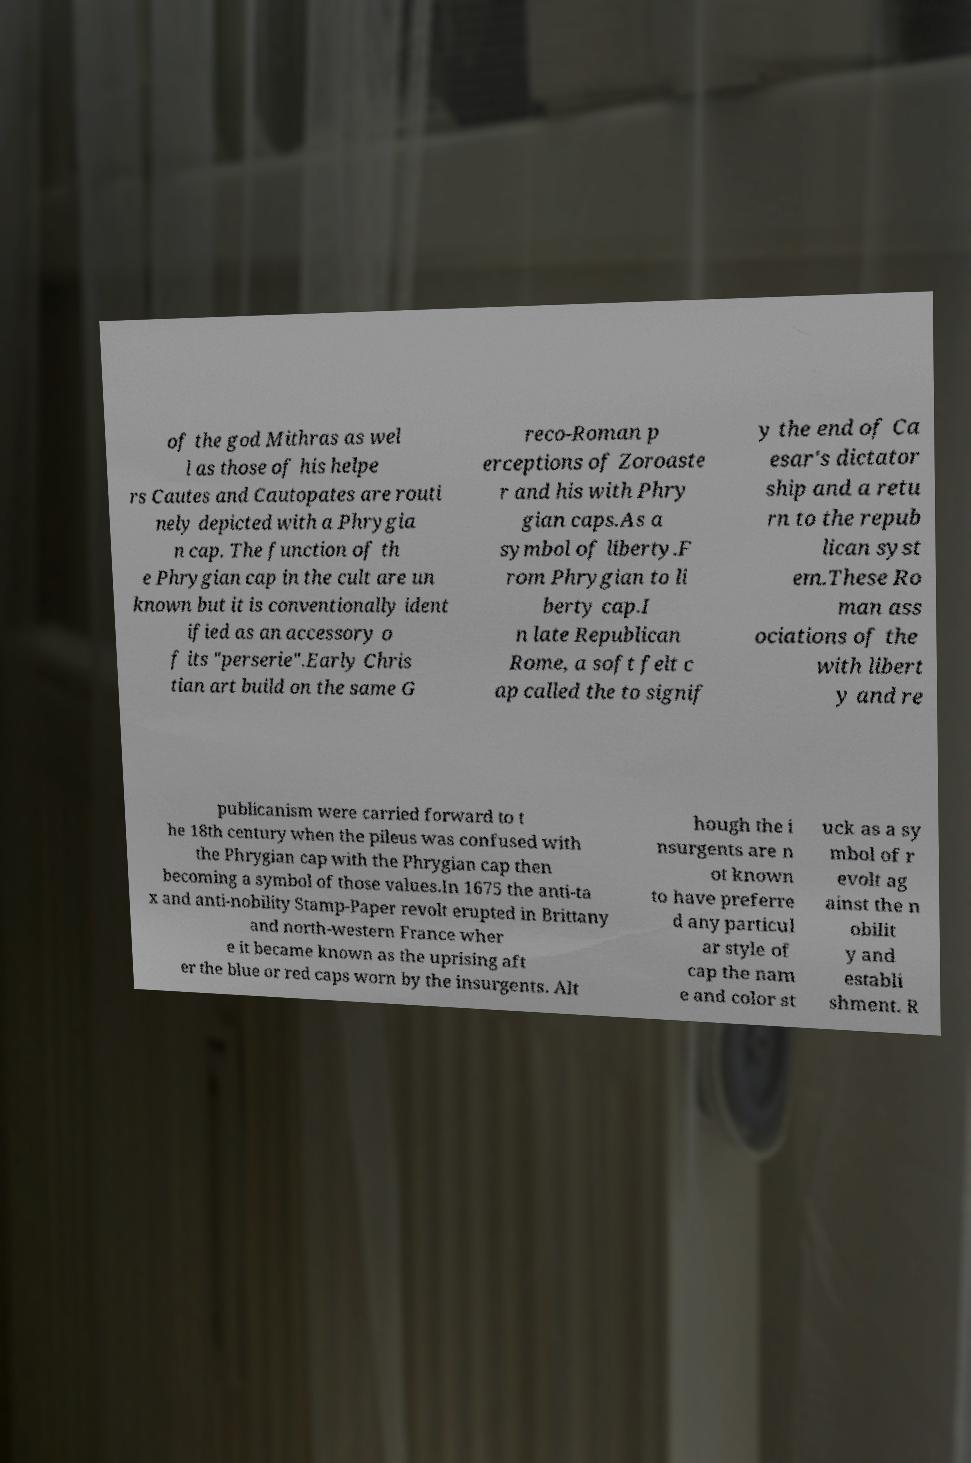What messages or text are displayed in this image? I need them in a readable, typed format. of the god Mithras as wel l as those of his helpe rs Cautes and Cautopates are routi nely depicted with a Phrygia n cap. The function of th e Phrygian cap in the cult are un known but it is conventionally ident ified as an accessory o f its "perserie".Early Chris tian art build on the same G reco-Roman p erceptions of Zoroaste r and his with Phry gian caps.As a symbol of liberty.F rom Phrygian to li berty cap.I n late Republican Rome, a soft felt c ap called the to signif y the end of Ca esar's dictator ship and a retu rn to the repub lican syst em.These Ro man ass ociations of the with libert y and re publicanism were carried forward to t he 18th century when the pileus was confused with the Phrygian cap with the Phrygian cap then becoming a symbol of those values.In 1675 the anti-ta x and anti-nobility Stamp-Paper revolt erupted in Brittany and north-western France wher e it became known as the uprising aft er the blue or red caps worn by the insurgents. Alt hough the i nsurgents are n ot known to have preferre d any particul ar style of cap the nam e and color st uck as a sy mbol of r evolt ag ainst the n obilit y and establi shment. R 